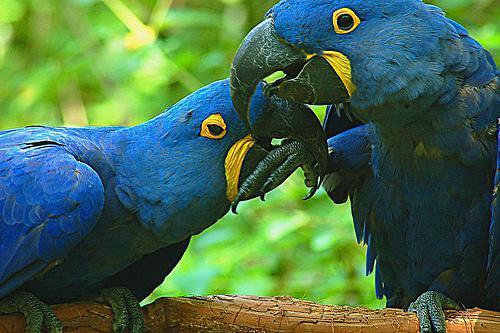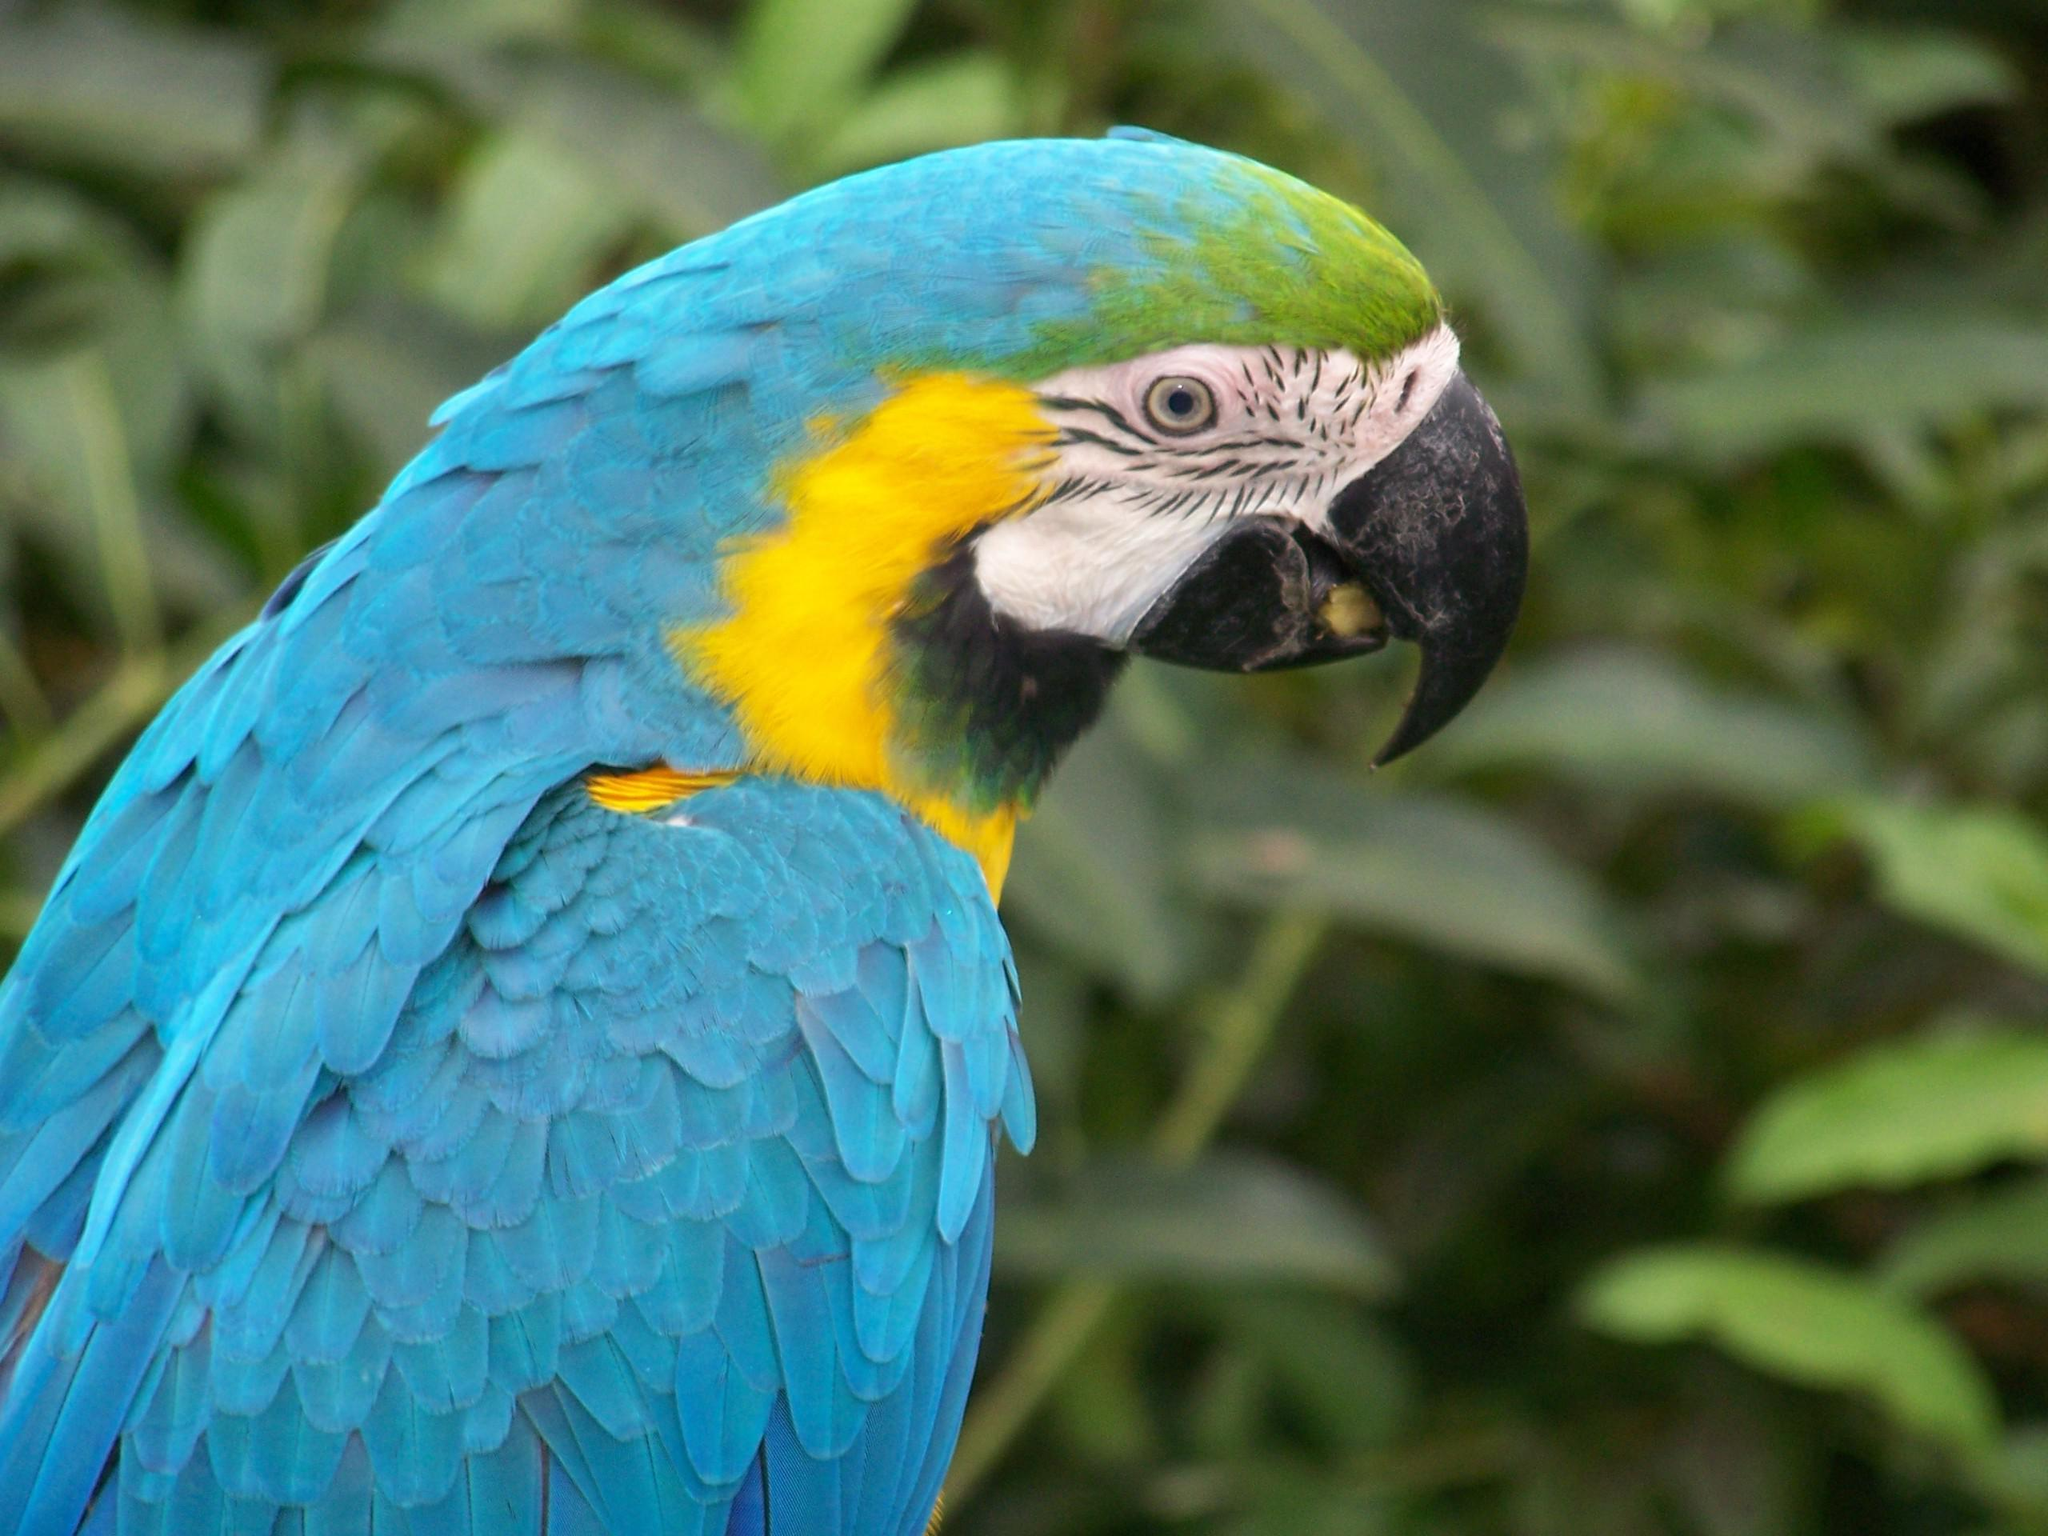The first image is the image on the left, the second image is the image on the right. Assess this claim about the two images: "There are two birds". Correct or not? Answer yes or no. No. 